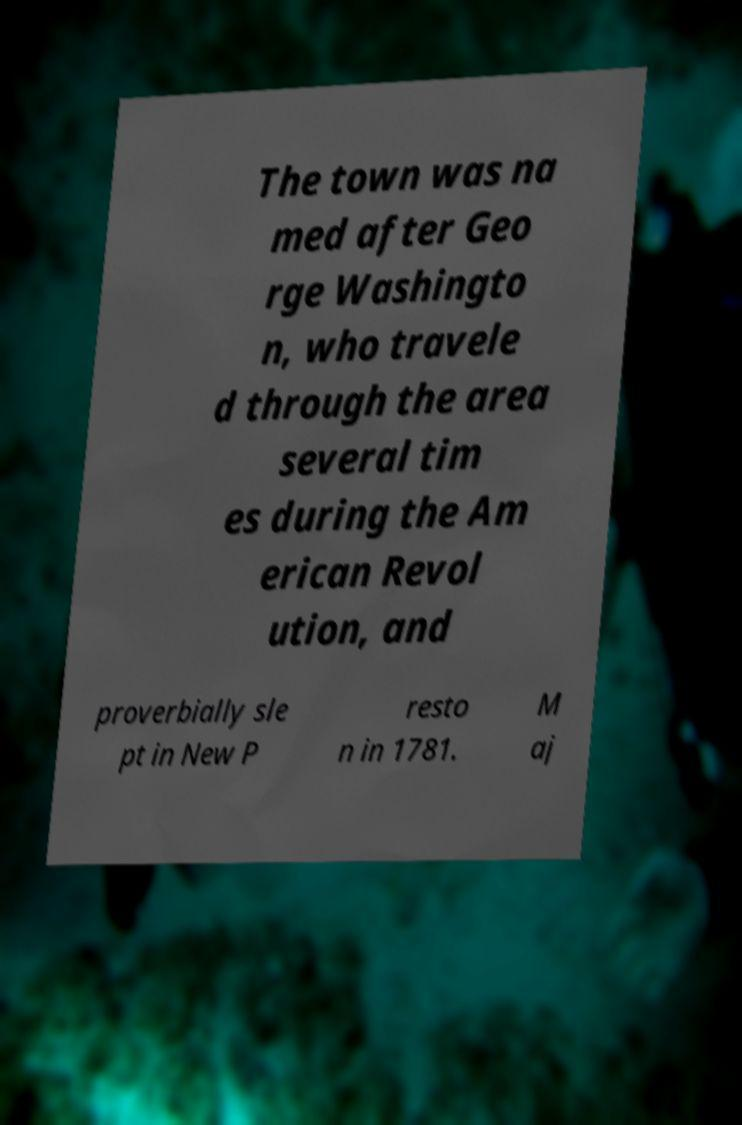There's text embedded in this image that I need extracted. Can you transcribe it verbatim? The town was na med after Geo rge Washingto n, who travele d through the area several tim es during the Am erican Revol ution, and proverbially sle pt in New P resto n in 1781. M aj 